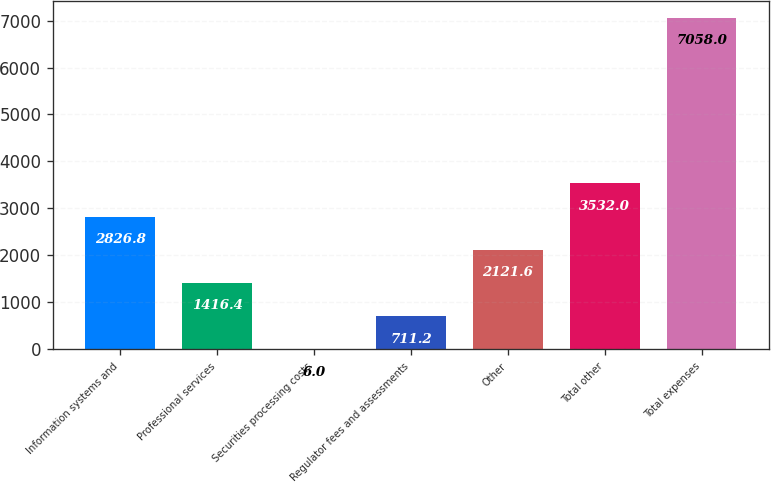Convert chart. <chart><loc_0><loc_0><loc_500><loc_500><bar_chart><fcel>Information systems and<fcel>Professional services<fcel>Securities processing costs<fcel>Regulator fees and assessments<fcel>Other<fcel>Total other<fcel>Total expenses<nl><fcel>2826.8<fcel>1416.4<fcel>6<fcel>711.2<fcel>2121.6<fcel>3532<fcel>7058<nl></chart> 